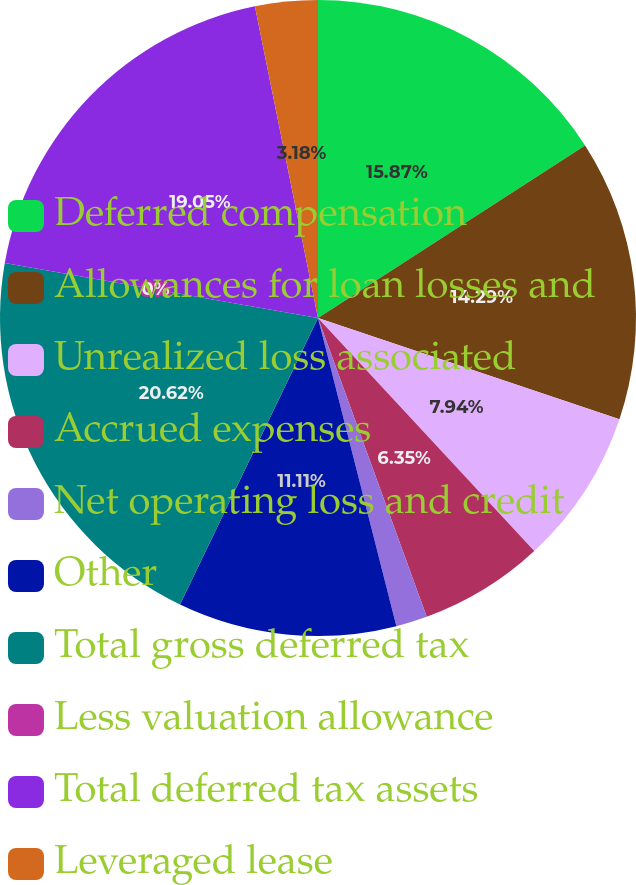Convert chart. <chart><loc_0><loc_0><loc_500><loc_500><pie_chart><fcel>Deferred compensation<fcel>Allowances for loan losses and<fcel>Unrealized loss associated<fcel>Accrued expenses<fcel>Net operating loss and credit<fcel>Other<fcel>Total gross deferred tax<fcel>Less valuation allowance<fcel>Total deferred tax assets<fcel>Leveraged lease<nl><fcel>15.87%<fcel>14.29%<fcel>7.94%<fcel>6.35%<fcel>1.59%<fcel>11.11%<fcel>20.63%<fcel>0.0%<fcel>19.05%<fcel>3.18%<nl></chart> 